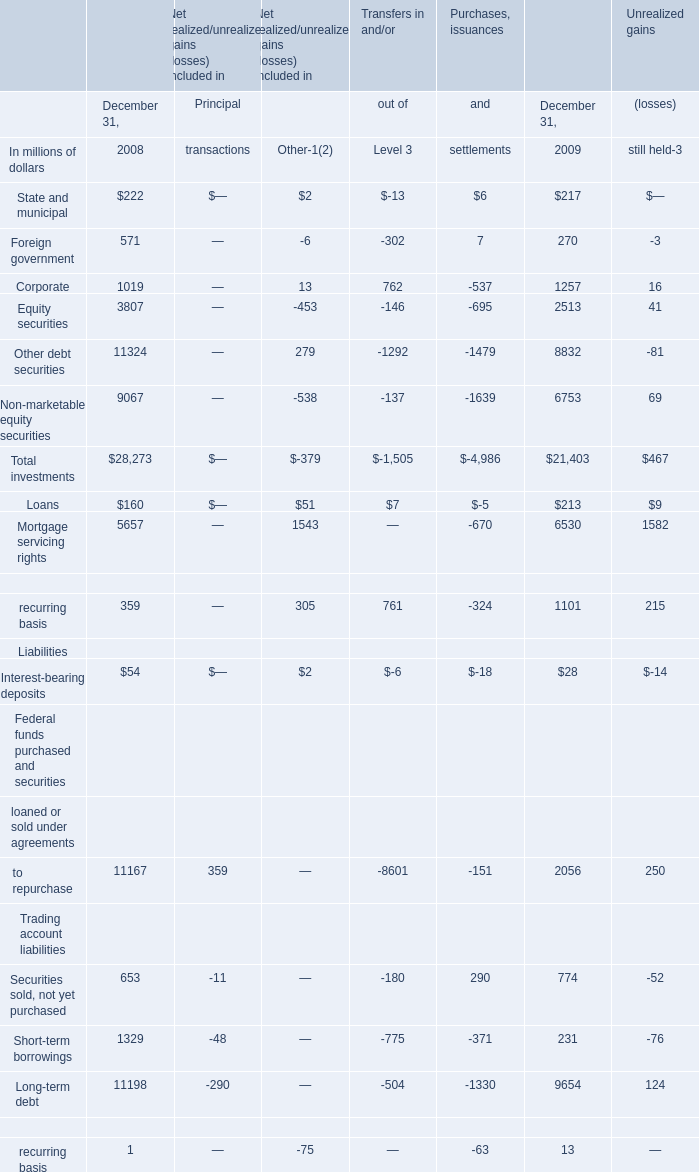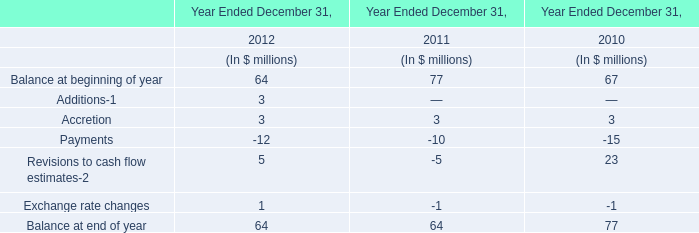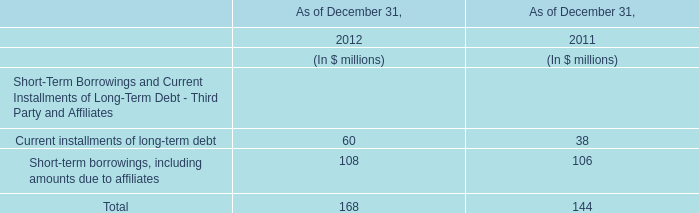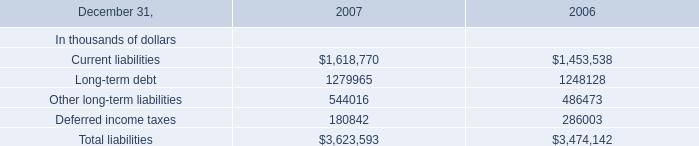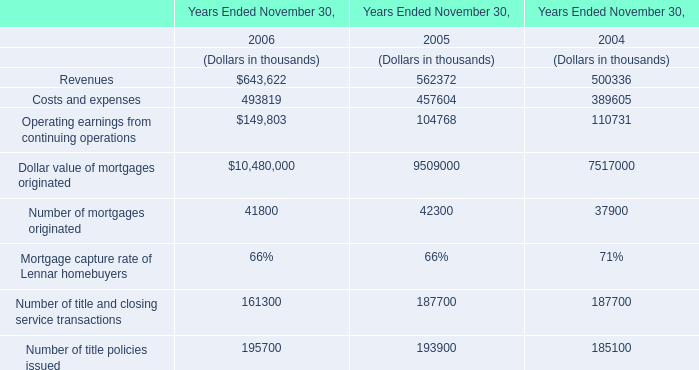What was the total amount of Long-term debt for section column heading excluding those Long-term debt for section column heading greater than 10000? (in millions of dollars) 
Computations: (((((-290 + 0) - 504) - 1330) + 9654) + 124)
Answer: 7654.0. 